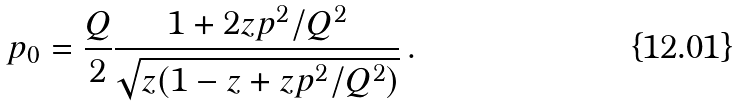Convert formula to latex. <formula><loc_0><loc_0><loc_500><loc_500>p _ { 0 } = \frac { Q } { 2 } \frac { 1 + 2 z p ^ { 2 } / Q ^ { 2 } } { \sqrt { z ( 1 - z + z p ^ { 2 } / Q ^ { 2 } ) } } \, .</formula> 